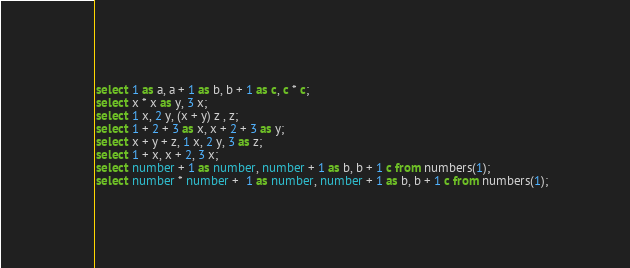<code> <loc_0><loc_0><loc_500><loc_500><_SQL_>select 1 as a, a + 1 as b, b + 1 as c, c * c;
select x * x as y, 3 x;
select 1 x, 2 y, (x + y) z , z;
select 1 + 2 + 3 as x, x + 2 + 3 as y;
select x + y + z, 1 x, 2 y, 3 as z;
select 1 + x, x + 2, 3 x;
select number + 1 as number, number + 1 as b, b + 1 c from numbers(1);
select number * number +  1 as number, number + 1 as b, b + 1 c from numbers(1);
</code> 